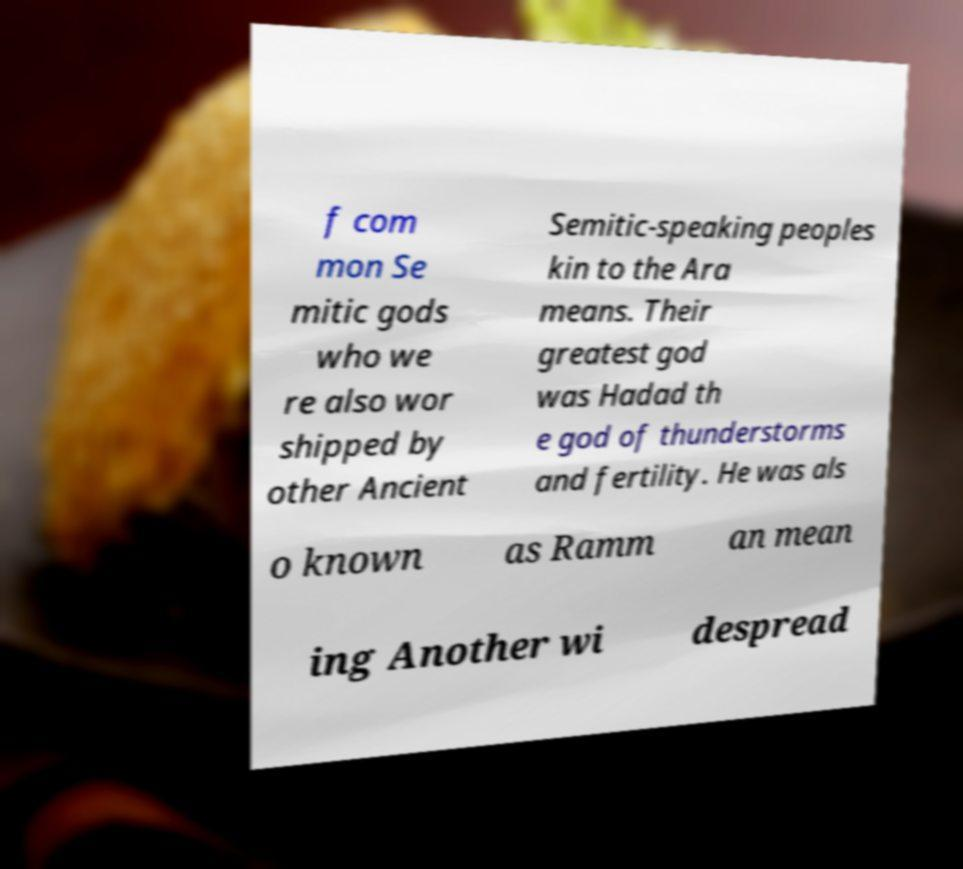Could you assist in decoding the text presented in this image and type it out clearly? f com mon Se mitic gods who we re also wor shipped by other Ancient Semitic-speaking peoples kin to the Ara means. Their greatest god was Hadad th e god of thunderstorms and fertility. He was als o known as Ramm an mean ing Another wi despread 